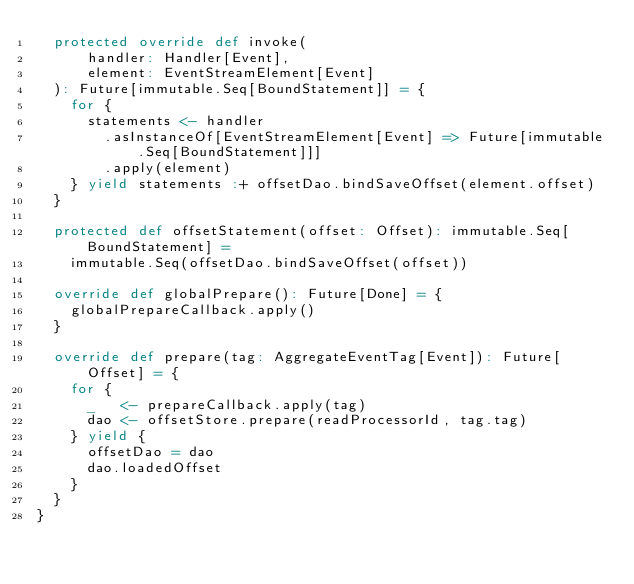<code> <loc_0><loc_0><loc_500><loc_500><_Scala_>  protected override def invoke(
      handler: Handler[Event],
      element: EventStreamElement[Event]
  ): Future[immutable.Seq[BoundStatement]] = {
    for {
      statements <- handler
        .asInstanceOf[EventStreamElement[Event] => Future[immutable.Seq[BoundStatement]]]
        .apply(element)
    } yield statements :+ offsetDao.bindSaveOffset(element.offset)
  }

  protected def offsetStatement(offset: Offset): immutable.Seq[BoundStatement] =
    immutable.Seq(offsetDao.bindSaveOffset(offset))

  override def globalPrepare(): Future[Done] = {
    globalPrepareCallback.apply()
  }

  override def prepare(tag: AggregateEventTag[Event]): Future[Offset] = {
    for {
      _   <- prepareCallback.apply(tag)
      dao <- offsetStore.prepare(readProcessorId, tag.tag)
    } yield {
      offsetDao = dao
      dao.loadedOffset
    }
  }
}
</code> 